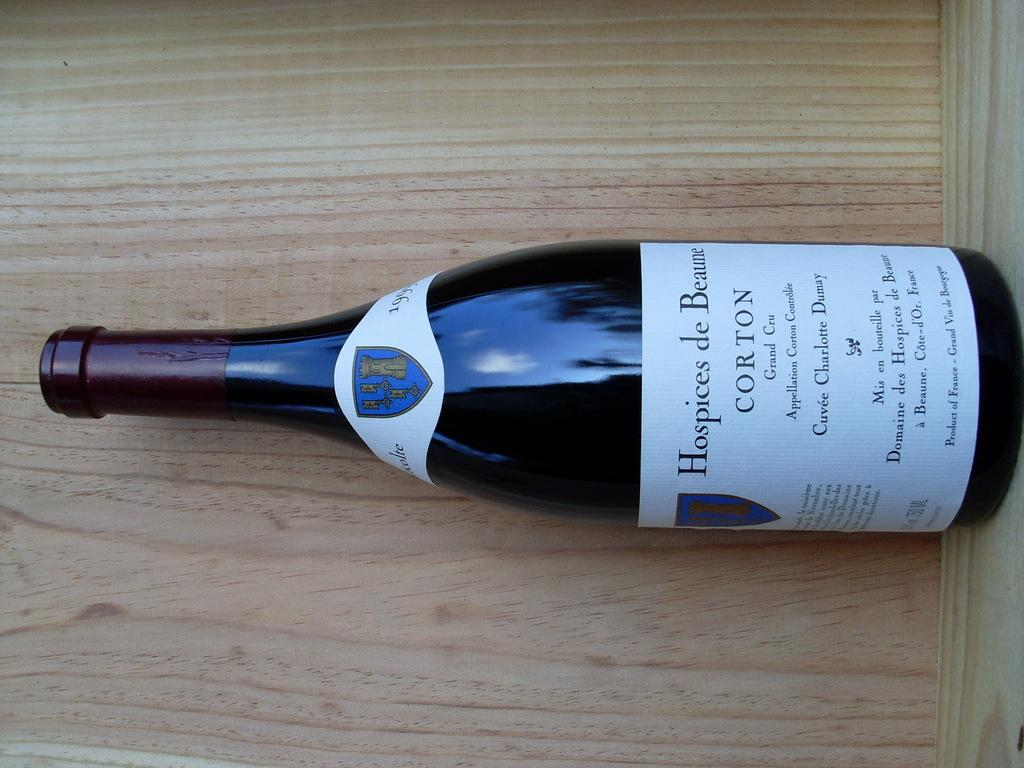Provide a one-sentence caption for the provided image. The bottle of wine is made in Beaune France and should be stored properly. 